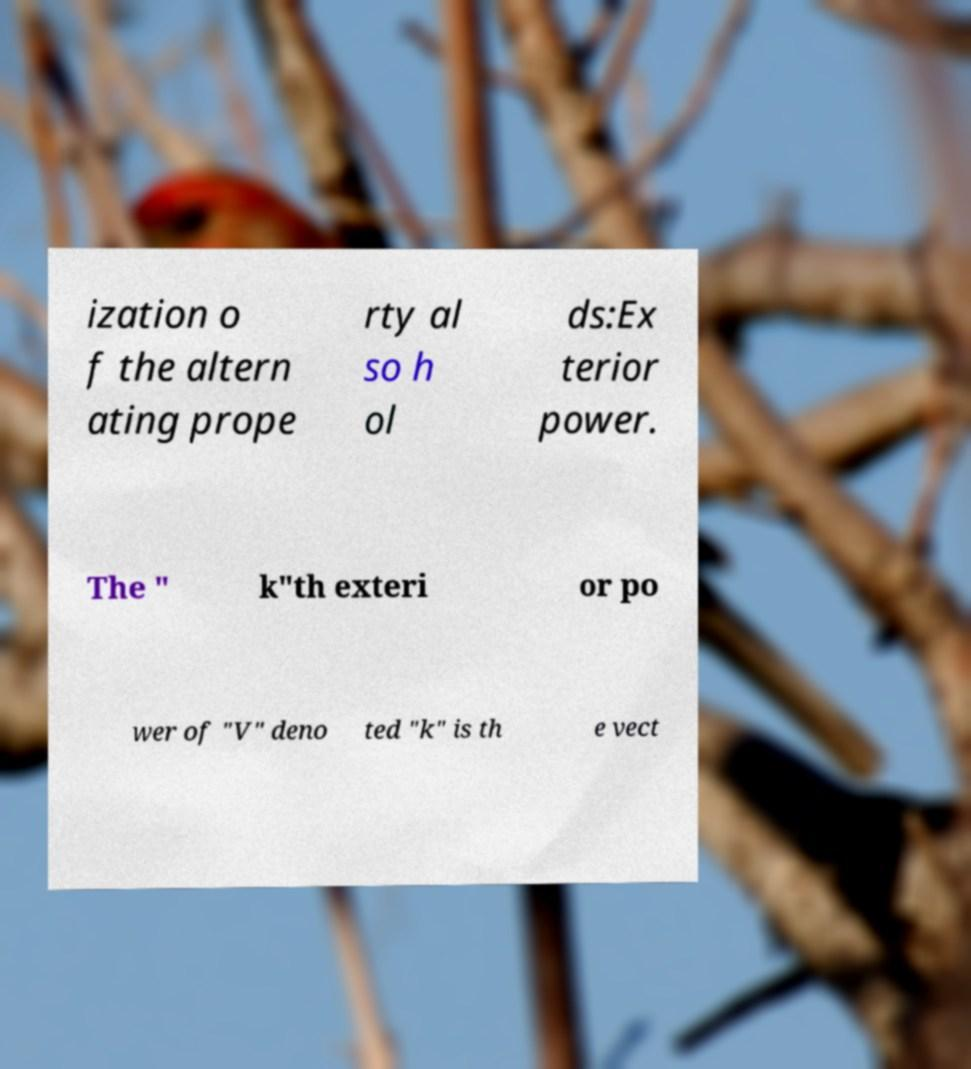For documentation purposes, I need the text within this image transcribed. Could you provide that? ization o f the altern ating prope rty al so h ol ds:Ex terior power. The " k"th exteri or po wer of "V" deno ted "k" is th e vect 